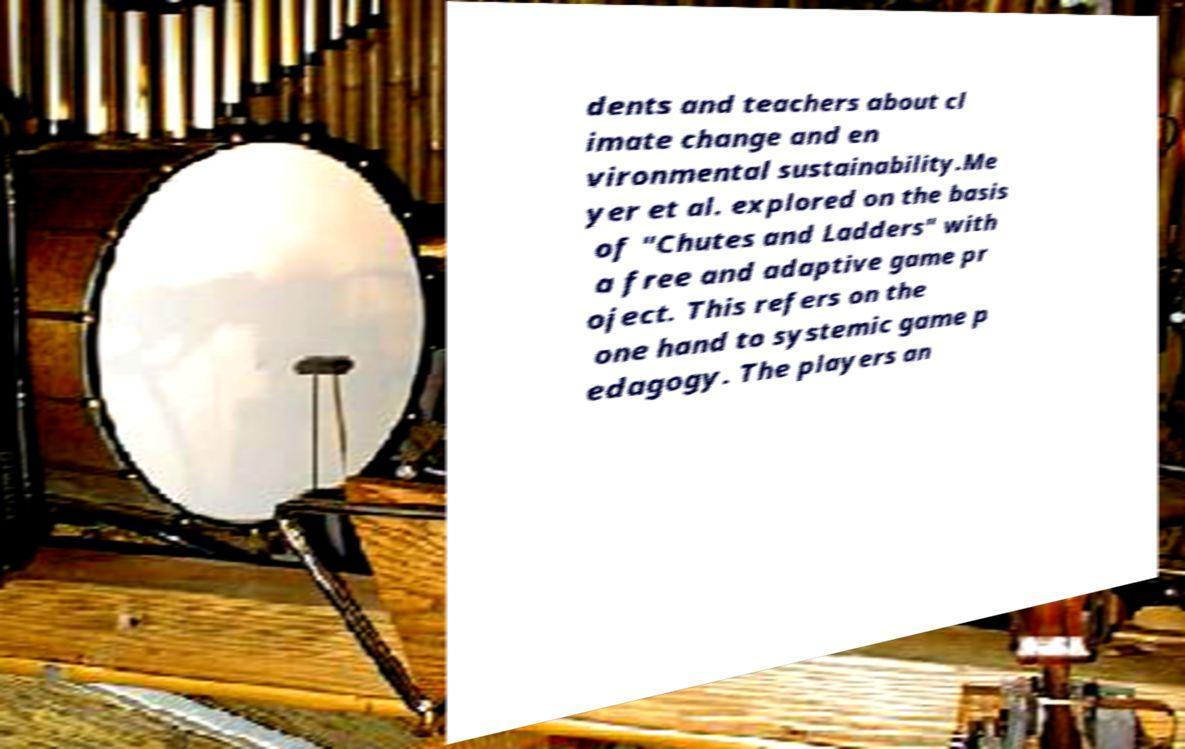Could you assist in decoding the text presented in this image and type it out clearly? dents and teachers about cl imate change and en vironmental sustainability.Me yer et al. explored on the basis of "Chutes and Ladders" with a free and adaptive game pr oject. This refers on the one hand to systemic game p edagogy. The players an 